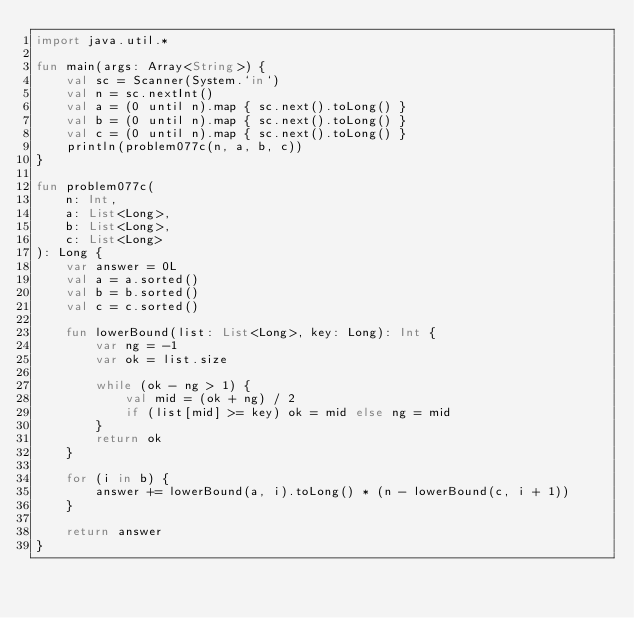Convert code to text. <code><loc_0><loc_0><loc_500><loc_500><_Kotlin_>import java.util.*

fun main(args: Array<String>) {
    val sc = Scanner(System.`in`)
    val n = sc.nextInt()
    val a = (0 until n).map { sc.next().toLong() }
    val b = (0 until n).map { sc.next().toLong() }
    val c = (0 until n).map { sc.next().toLong() }
    println(problem077c(n, a, b, c))
}

fun problem077c(
    n: Int,
    a: List<Long>,
    b: List<Long>,
    c: List<Long>
): Long {
    var answer = 0L
    val a = a.sorted()
    val b = b.sorted()
    val c = c.sorted()

    fun lowerBound(list: List<Long>, key: Long): Int {
        var ng = -1
        var ok = list.size

        while (ok - ng > 1) {
            val mid = (ok + ng) / 2
            if (list[mid] >= key) ok = mid else ng = mid
        }
        return ok
    }

    for (i in b) {
        answer += lowerBound(a, i).toLong() * (n - lowerBound(c, i + 1))
    }

    return answer
}</code> 